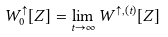Convert formula to latex. <formula><loc_0><loc_0><loc_500><loc_500>W ^ { \uparrow } _ { 0 } [ Z ] = \lim _ { t \to \infty } W ^ { \uparrow , ( t ) } [ Z ]</formula> 